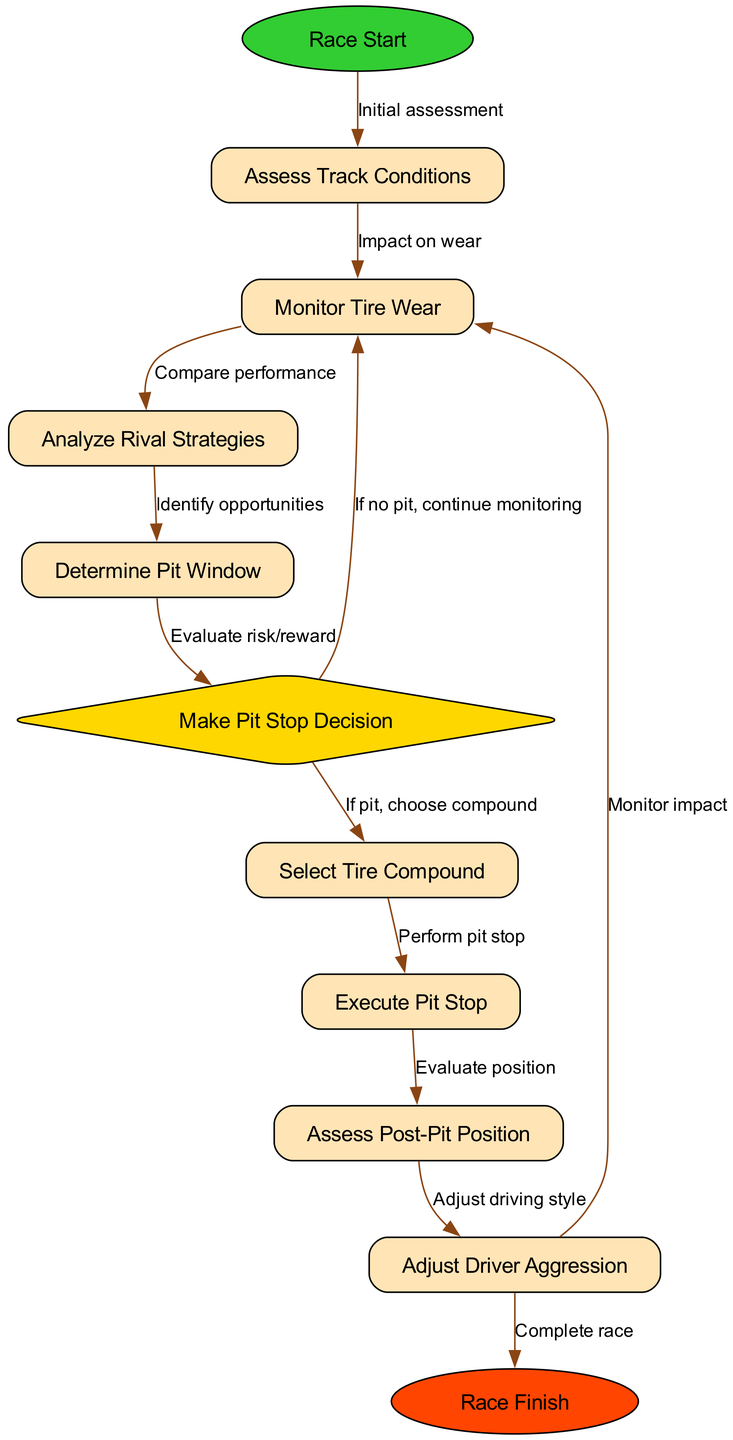What is the starting point of the flowchart? The starting point of the flowchart is labeled as "Race Start." It is the first node that initiates the entire process outlined in the diagram.
Answer: Race Start How many nodes are present in the flowchart? By counting all the nodes listed, there are a total of 11 nodes contributing to the decision-making process during the Grand Prix.
Answer: 11 What does the "pit_decision" node indicate? The "pit_decision" node signifies a critical decision point where the strategy of whether or not to pit is determined based on prior evaluations and conditions. This node is also represented as a diamond shape in the diagram indicating a decision point.
Answer: Make Pit Stop Decision What follows after the "Execute Pit Stop" node? After the "Execute Pit Stop" node, the next step is to "Assess Post-Pit Position," which involves evaluating the driver's standing after the pit stop has been completed.
Answer: Assess Post-Pit Position What action is taken if the "pit_decision" node results in no pit stop? If the decision at the "pit_decision" node is to not pit, the alternative action is to continue monitoring tire wear as indicated in the flowchart.
Answer: Continue monitoring What factors influence the "Make Pit Stop Decision" node? The decision at this node is influenced by evaluating the risk/reward associated with pitting as well as monitoring tire wear, and these factors culminate into determining optimal race strategy.
Answer: Risk/reward evaluation What is the final outcome of the flowchart? The final outcome of the flowchart is marked as "Race Finish," indicating the conclusion of the race strategy decision-making process implemented during the Grand Prix.
Answer: Race Finish How many edges are connecting the nodes in the diagram? By reviewing the edges listed that connect the nodes, there are a total of 12 edges illustrating the relationships between the various steps in the flowchart.
Answer: 12 What does the "Adjust Driver Aggression" node lead to after evaluation? After the evaluation at the "Adjust Driver Aggression" node, the next action is to "Complete race," signifying that adjustments in driving style affect the conclusion of the race.
Answer: Complete race 